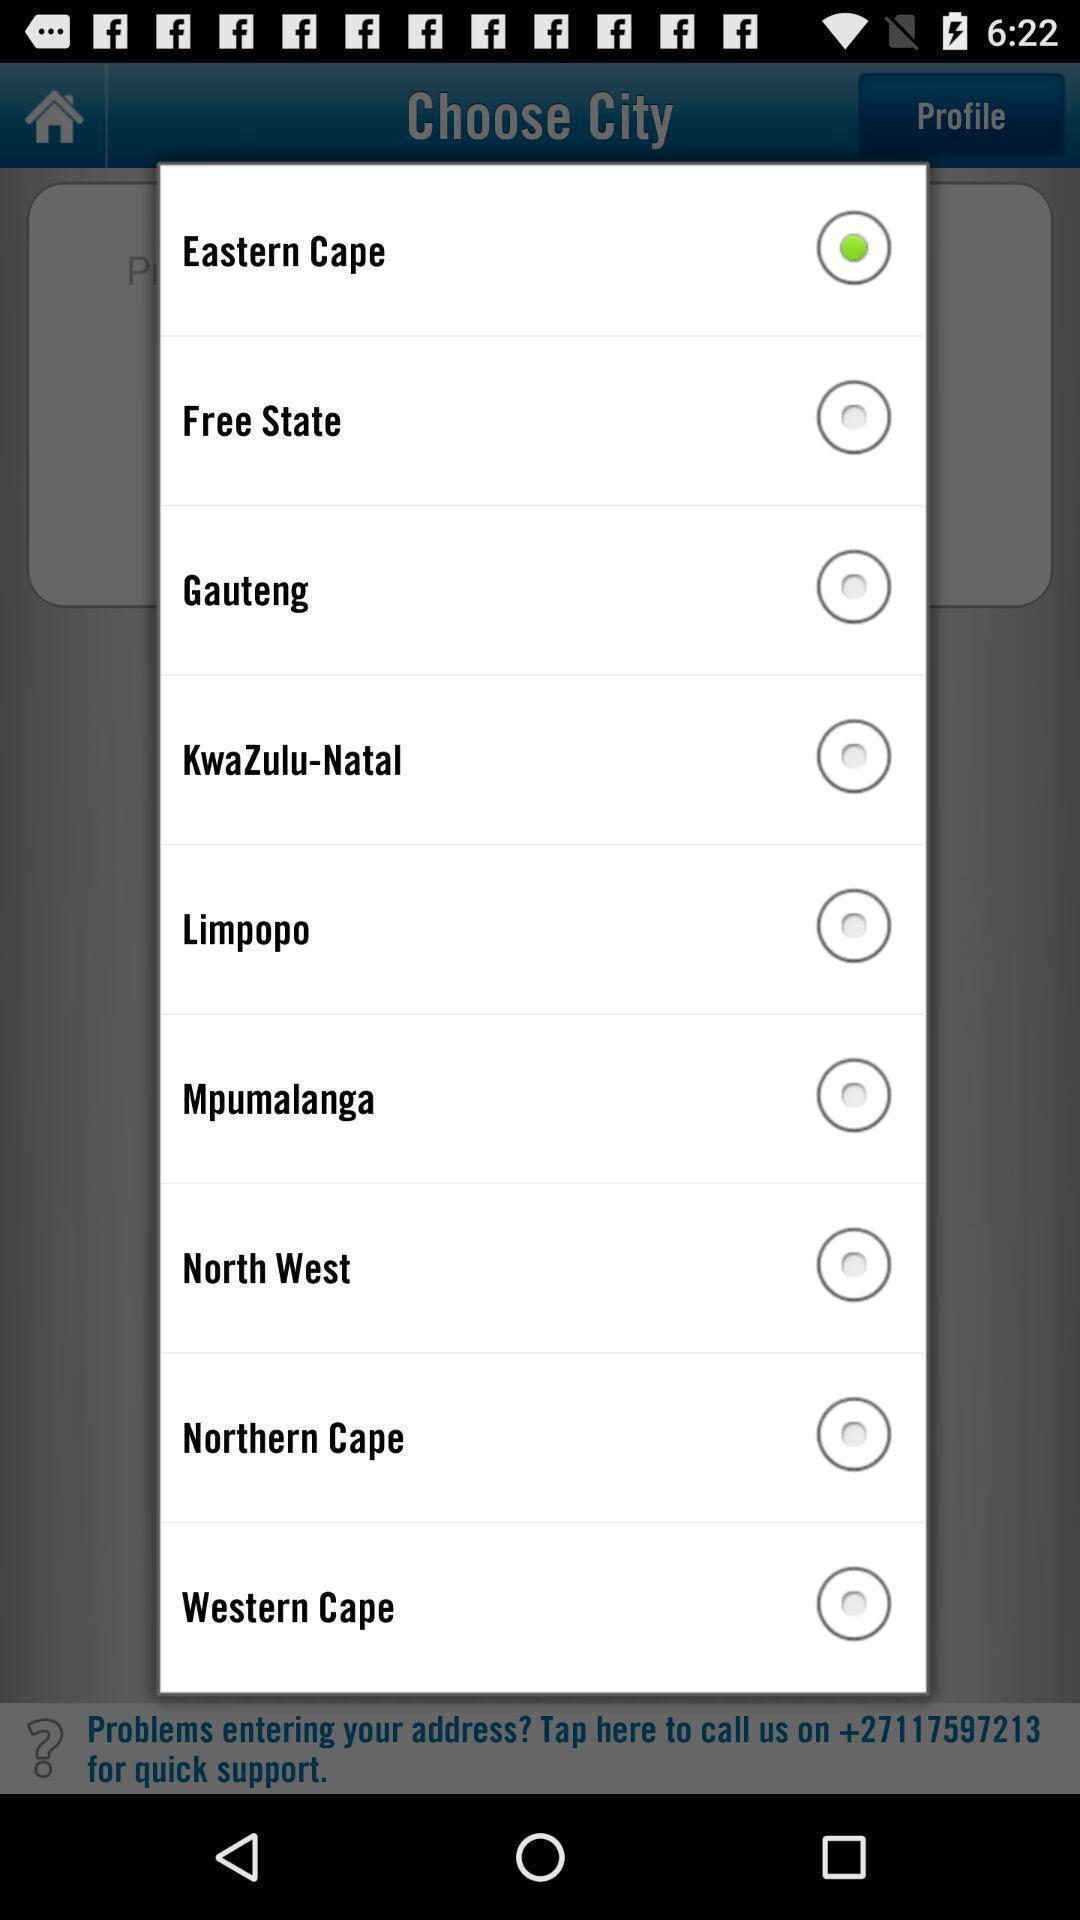What is the overall content of this screenshot? Push up displaying list of cities. 